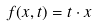<formula> <loc_0><loc_0><loc_500><loc_500>f ( x , t ) = t \cdot x</formula> 